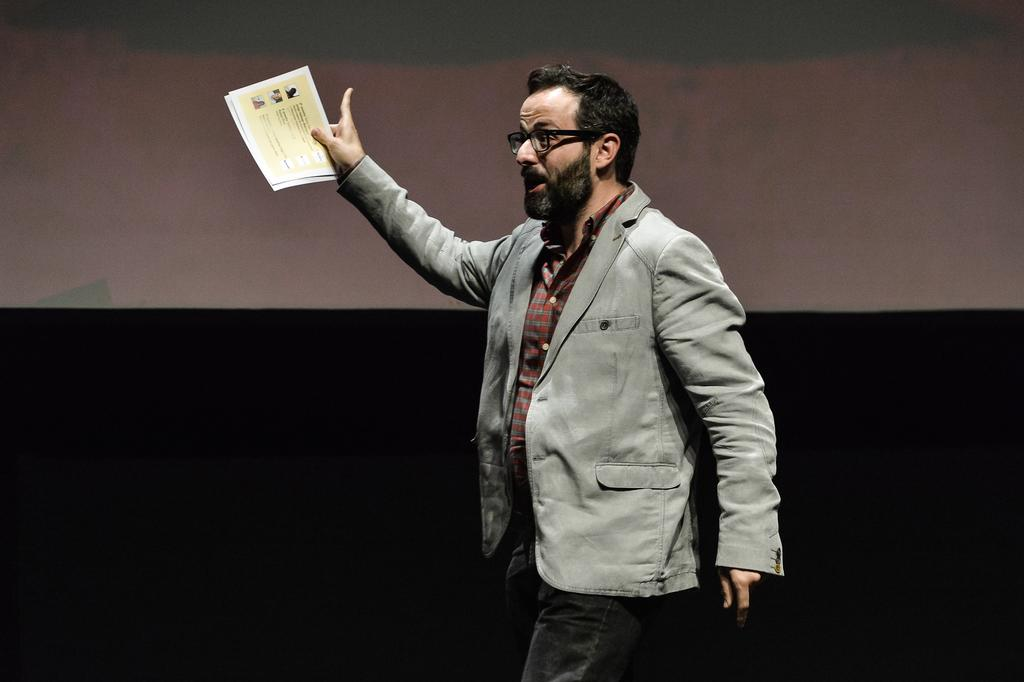What is the main subject of the image? There is a person in the image. Can you describe the person's clothing? The person is wearing a grey jacket, a shirt, and jeans. What accessory is the person wearing? The person is wearing spectacles. What is the person holding in their hands? The person is holding papers in their hands. What is the person's posture in the image? The person is standing. What can be seen in the background of the image? The background of the image is dark. What type of pipe can be seen in the image? There is no pipe present in the image. How does the person's presence in the image affect society? The image does not provide enough information to determine the person's impact on society. 